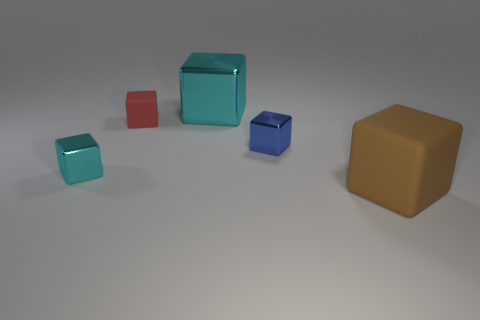There is a metallic thing that is in front of the tiny red rubber object and right of the small red matte object; what color is it?
Make the answer very short. Blue. The blue shiny object that is the same shape as the red matte object is what size?
Your answer should be very brief. Small. What number of matte things are the same size as the red block?
Keep it short and to the point. 0. What material is the small red object?
Your answer should be compact. Rubber. There is a big cyan cube; are there any large shiny objects behind it?
Provide a short and direct response. No. There is a blue thing that is the same material as the large cyan object; what is its size?
Keep it short and to the point. Small. What number of matte cubes are the same color as the large shiny block?
Keep it short and to the point. 0. Are there fewer large blocks that are behind the large brown thing than large cyan cubes on the left side of the tiny matte cube?
Offer a terse response. No. What is the size of the rubber block on the left side of the big shiny cube?
Keep it short and to the point. Small. There is another block that is the same color as the big metal block; what is its size?
Give a very brief answer. Small. 